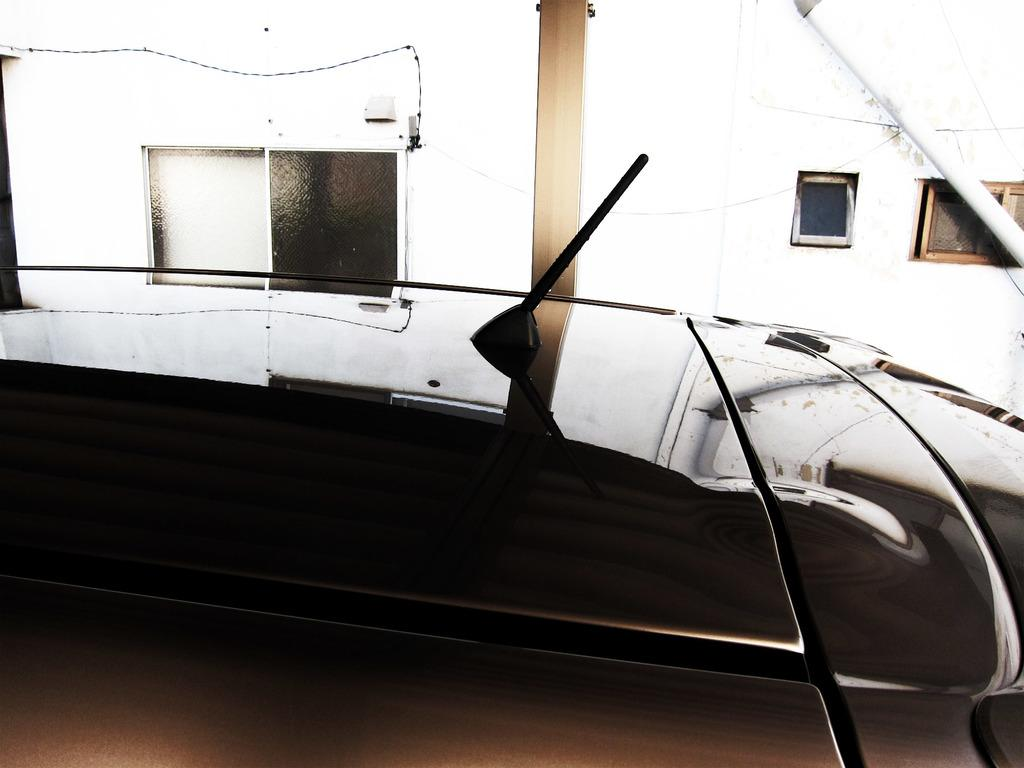What is the main subject of the image? There is a vehicle in the image. What feature can be seen on the vehicle? The vehicle has an antenna. What can be observed in the image besides the vehicle? There are reflections visible in the image. What type of structures can be seen in the background of the image? There are glass windows, a wall, a pillar, and a pole in the background of the image. What type of snails can be seen crawling on the vehicle in the image? There are no snails visible on the vehicle in the image. What flavor of sugar is being used to sweeten the vehicle in the image? There is no sugar or flavor mentioned or depicted in the image, as it features a vehicle with an antenna and various background structures. 